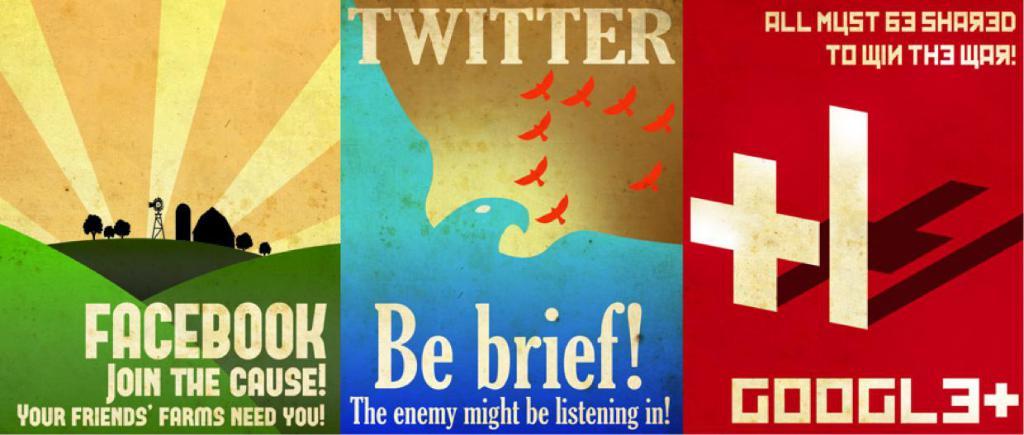What social media platform is mentioned in the middle poster?
Make the answer very short. Twitter. What is the social media in red?
Give a very brief answer. Google+. 